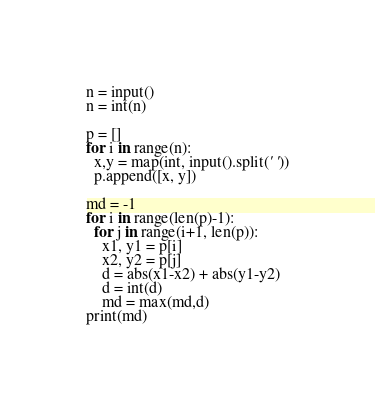<code> <loc_0><loc_0><loc_500><loc_500><_Python_>n = input()
n = int(n)

p = []
for i in range(n):
  x,y = map(int, input().split(' '))
  p.append([x, y])

md = -1
for i in range(len(p)-1):
  for j in range(i+1, len(p)):
    x1, y1 = p[i]
    x2, y2 = p[j]
    d = abs(x1-x2) + abs(y1-y2)
    d = int(d)
    md = max(md,d)
print(md)</code> 